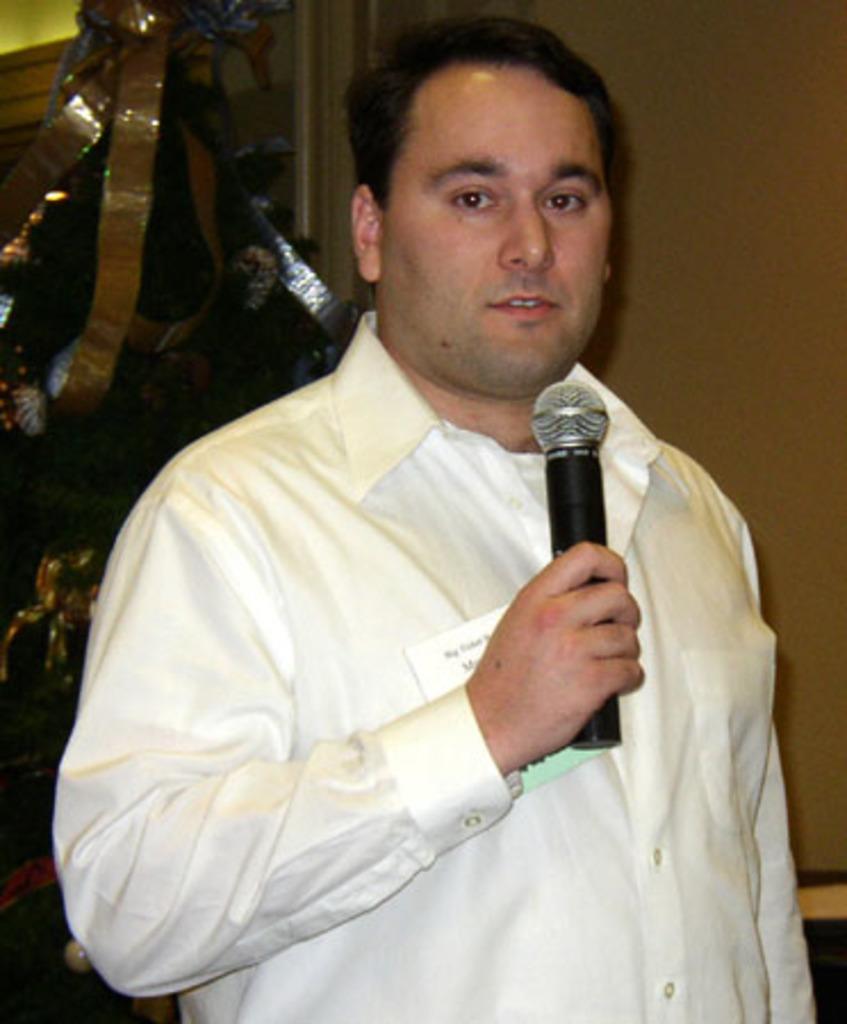Can you describe this image briefly? In this picture we can see a man standing and holding a microphone, he wore a shirt, we can see paper here, in the background there is a wall, we can see cloth here. 